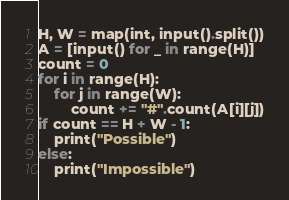Convert code to text. <code><loc_0><loc_0><loc_500><loc_500><_Python_>H, W = map(int, input().split())
A = [input() for _ in range(H)]
count = 0
for i in range(H):
    for j in range(W):
        count += "#".count(A[i][j])
if count == H + W - 1:
    print("Possible")
else:
    print("Impossible")
</code> 